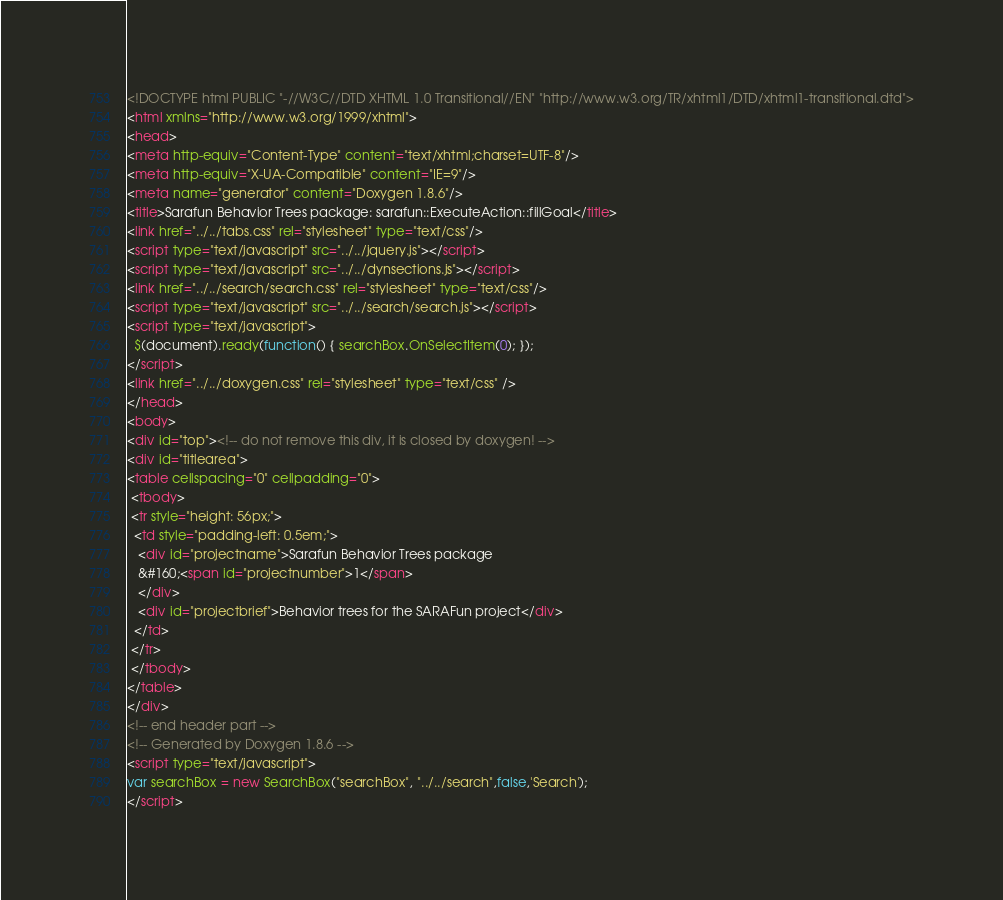Convert code to text. <code><loc_0><loc_0><loc_500><loc_500><_HTML_><!DOCTYPE html PUBLIC "-//W3C//DTD XHTML 1.0 Transitional//EN" "http://www.w3.org/TR/xhtml1/DTD/xhtml1-transitional.dtd">
<html xmlns="http://www.w3.org/1999/xhtml">
<head>
<meta http-equiv="Content-Type" content="text/xhtml;charset=UTF-8"/>
<meta http-equiv="X-UA-Compatible" content="IE=9"/>
<meta name="generator" content="Doxygen 1.8.6"/>
<title>Sarafun Behavior Trees package: sarafun::ExecuteAction::fillGoal</title>
<link href="../../tabs.css" rel="stylesheet" type="text/css"/>
<script type="text/javascript" src="../../jquery.js"></script>
<script type="text/javascript" src="../../dynsections.js"></script>
<link href="../../search/search.css" rel="stylesheet" type="text/css"/>
<script type="text/javascript" src="../../search/search.js"></script>
<script type="text/javascript">
  $(document).ready(function() { searchBox.OnSelectItem(0); });
</script>
<link href="../../doxygen.css" rel="stylesheet" type="text/css" />
</head>
<body>
<div id="top"><!-- do not remove this div, it is closed by doxygen! -->
<div id="titlearea">
<table cellspacing="0" cellpadding="0">
 <tbody>
 <tr style="height: 56px;">
  <td style="padding-left: 0.5em;">
   <div id="projectname">Sarafun Behavior Trees package
   &#160;<span id="projectnumber">1</span>
   </div>
   <div id="projectbrief">Behavior trees for the SARAFun project</div>
  </td>
 </tr>
 </tbody>
</table>
</div>
<!-- end header part -->
<!-- Generated by Doxygen 1.8.6 -->
<script type="text/javascript">
var searchBox = new SearchBox("searchBox", "../../search",false,'Search');
</script></code> 